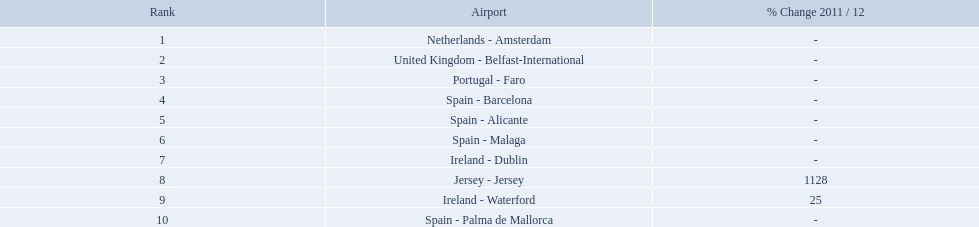What are the airports? Netherlands - Amsterdam, United Kingdom - Belfast-International, Portugal - Faro, Spain - Barcelona, Spain - Alicante, Spain - Malaga, Ireland - Dublin, Jersey - Jersey, Ireland - Waterford, Spain - Palma de Mallorca. Of these which has the least amount of passengers? Spain - Palma de Mallorca. How many passengers did the united kingdom handle? 92,502. Who handled more passengers than this? Netherlands - Amsterdam. What are all of the airports? Netherlands - Amsterdam, United Kingdom - Belfast-International, Portugal - Faro, Spain - Barcelona, Spain - Alicante, Spain - Malaga, Ireland - Dublin, Jersey - Jersey, Ireland - Waterford, Spain - Palma de Mallorca. How many passengers have they handled? 105,349, 92,502, 71,676, 66,565, 64,090, 59,175, 35,524, 35,169, 31,907, 27,718. And which airport has handled the most passengers? Netherlands - Amsterdam. What are all the airports in the top 10 busiest routes to and from london southend airport? Netherlands - Amsterdam, United Kingdom - Belfast-International, Portugal - Faro, Spain - Barcelona, Spain - Alicante, Spain - Malaga, Ireland - Dublin, Jersey - Jersey, Ireland - Waterford, Spain - Palma de Mallorca. Which airports are in portugal? Portugal - Faro. What is the highest number of passengers handled? 105,349. What is the destination of the passengers leaving the area that handles 105,349 travellers? Netherlands - Amsterdam. 